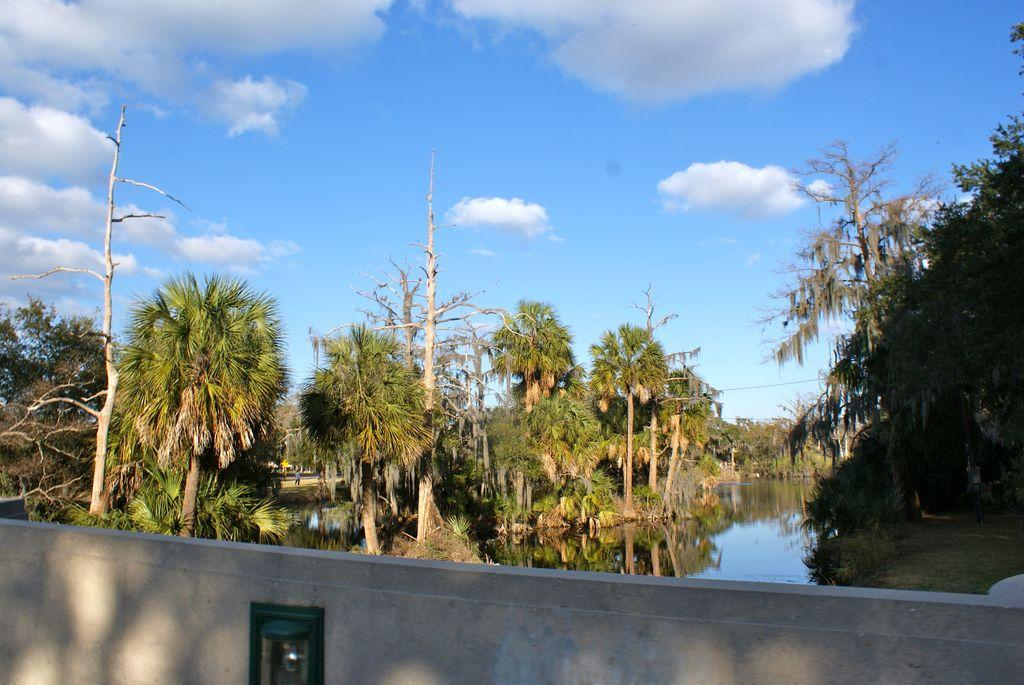What type of structure can be seen in the image? There is a wall in the image. What natural element is visible in the image? There is water visible in the image. What type of vegetation is present in the image? There is grass in the image. Can you describe the person in the image? There is a person in the image. What other natural elements can be seen in the image? There are trees in the image. What is visible in the background of the image? The sky is visible in the background of the image. How many fingers can be seen in the image? There are no fingers visible in the image. 